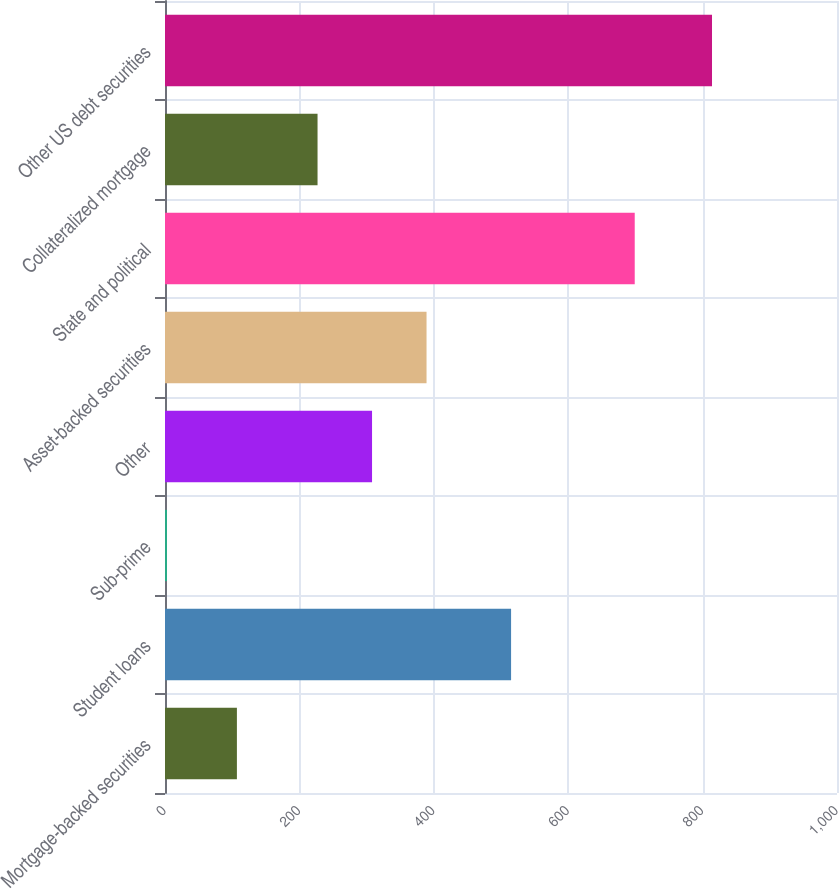Convert chart. <chart><loc_0><loc_0><loc_500><loc_500><bar_chart><fcel>Mortgage-backed securities<fcel>Student loans<fcel>Sub-prime<fcel>Other<fcel>Asset-backed securities<fcel>State and political<fcel>Collateralized mortgage<fcel>Other US debt securities<nl><fcel>107<fcel>515<fcel>3<fcel>308.1<fcel>389.2<fcel>699<fcel>227<fcel>814<nl></chart> 